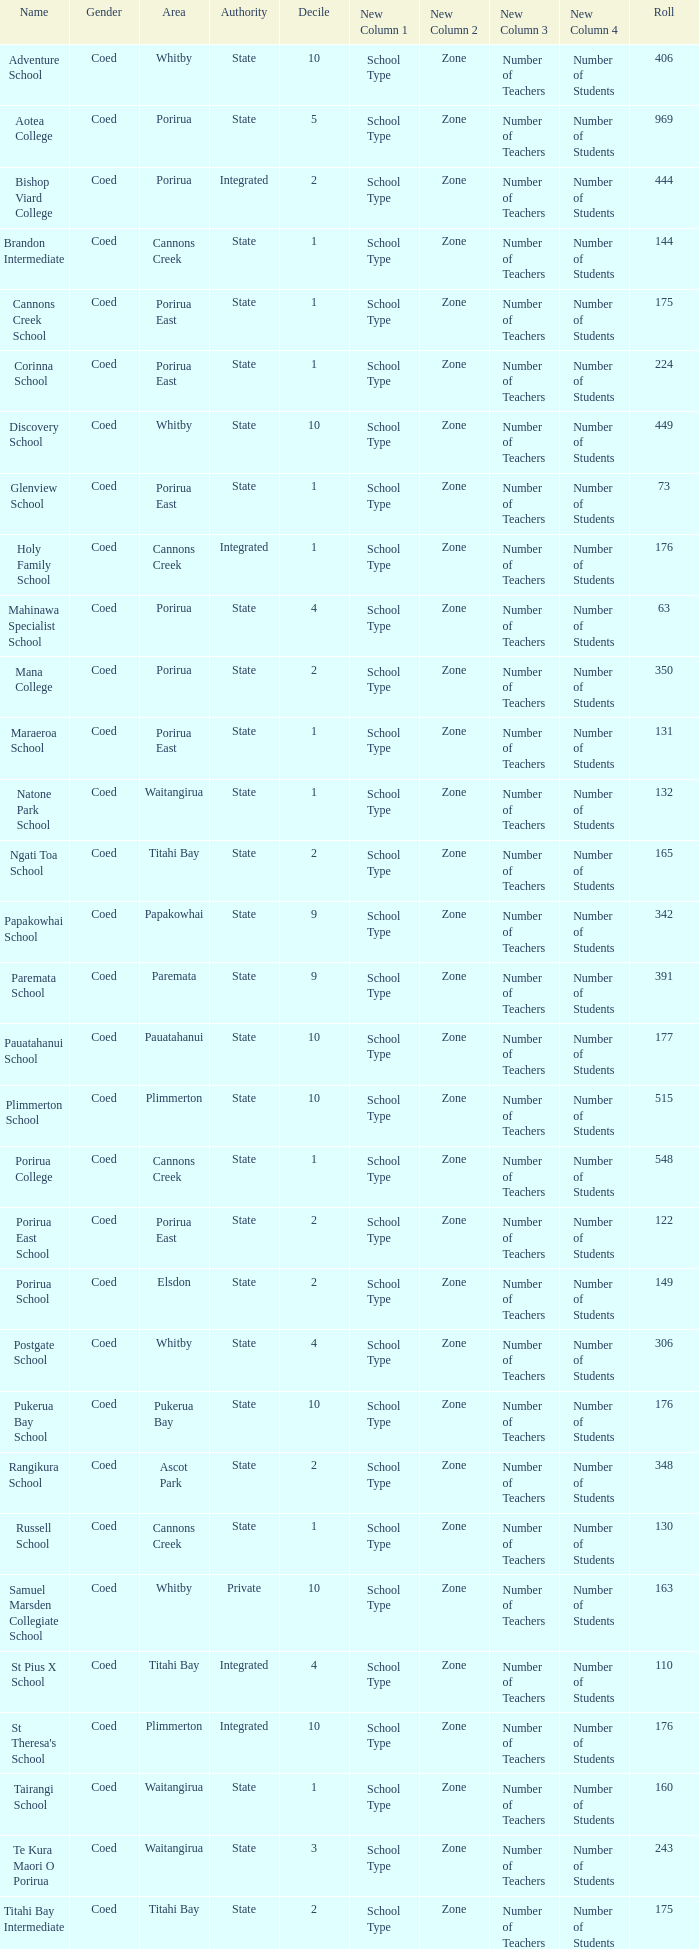What is the roll of Bishop Viard College (An Integrated College), which has a decile larger than 1? 1.0. 